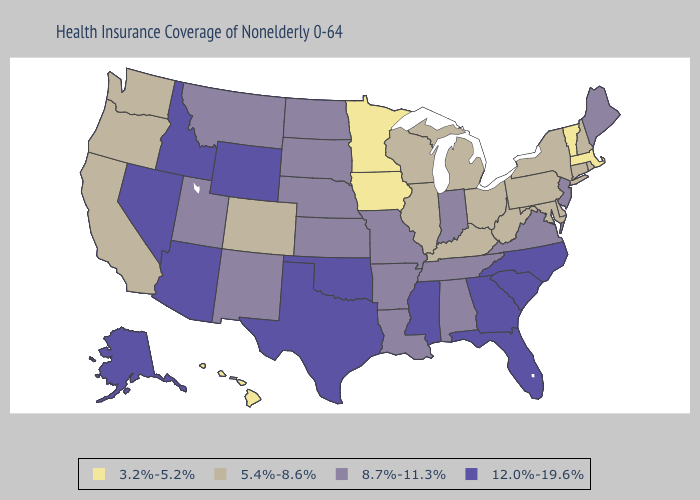Name the states that have a value in the range 12.0%-19.6%?
Quick response, please. Alaska, Arizona, Florida, Georgia, Idaho, Mississippi, Nevada, North Carolina, Oklahoma, South Carolina, Texas, Wyoming. Does Montana have a lower value than Idaho?
Keep it brief. Yes. Name the states that have a value in the range 12.0%-19.6%?
Concise answer only. Alaska, Arizona, Florida, Georgia, Idaho, Mississippi, Nevada, North Carolina, Oklahoma, South Carolina, Texas, Wyoming. What is the value of Iowa?
Keep it brief. 3.2%-5.2%. Does Maine have a higher value than Virginia?
Concise answer only. No. Name the states that have a value in the range 5.4%-8.6%?
Be succinct. California, Colorado, Connecticut, Delaware, Illinois, Kentucky, Maryland, Michigan, New Hampshire, New York, Ohio, Oregon, Pennsylvania, Rhode Island, Washington, West Virginia, Wisconsin. What is the value of Oregon?
Give a very brief answer. 5.4%-8.6%. What is the lowest value in the USA?
Keep it brief. 3.2%-5.2%. Name the states that have a value in the range 5.4%-8.6%?
Write a very short answer. California, Colorado, Connecticut, Delaware, Illinois, Kentucky, Maryland, Michigan, New Hampshire, New York, Ohio, Oregon, Pennsylvania, Rhode Island, Washington, West Virginia, Wisconsin. Which states have the highest value in the USA?
Keep it brief. Alaska, Arizona, Florida, Georgia, Idaho, Mississippi, Nevada, North Carolina, Oklahoma, South Carolina, Texas, Wyoming. Name the states that have a value in the range 8.7%-11.3%?
Give a very brief answer. Alabama, Arkansas, Indiana, Kansas, Louisiana, Maine, Missouri, Montana, Nebraska, New Jersey, New Mexico, North Dakota, South Dakota, Tennessee, Utah, Virginia. What is the value of Alabama?
Concise answer only. 8.7%-11.3%. What is the value of Hawaii?
Concise answer only. 3.2%-5.2%. Is the legend a continuous bar?
Quick response, please. No. Among the states that border Virginia , does North Carolina have the highest value?
Give a very brief answer. Yes. 